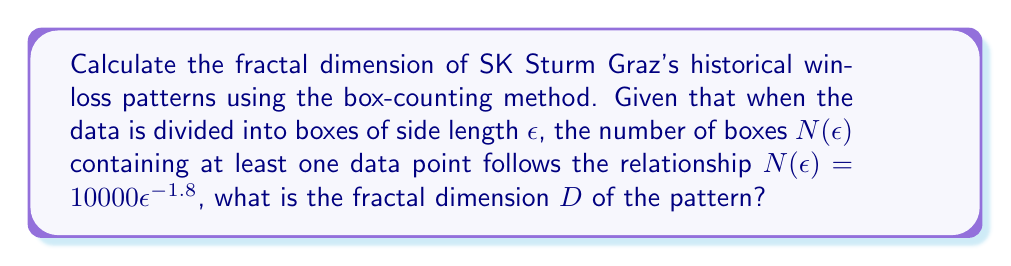Show me your answer to this math problem. To determine the fractal dimension using the box-counting method, we follow these steps:

1. Recall the box-counting dimension formula:
   $$D = \lim_{\epsilon \to 0} \frac{\log N(\epsilon)}{\log(1/\epsilon)}$$

2. We're given that $N(\epsilon) = 10000\epsilon^{-1.8}$

3. Take the logarithm of both sides:
   $$\log N(\epsilon) = \log(10000\epsilon^{-1.8})$$

4. Use the properties of logarithms:
   $$\log N(\epsilon) = \log 10000 + \log(\epsilon^{-1.8})$$
   $$\log N(\epsilon) = 4 - 1.8\log(\epsilon)$$

5. Divide both sides by $\log(1/\epsilon)$:
   $$\frac{\log N(\epsilon)}{\log(1/\epsilon)} = \frac{4}{\log(1/\epsilon)} + 1.8$$

6. As $\epsilon \to 0$, $\log(1/\epsilon) \to \infty$, so $\frac{4}{\log(1/\epsilon)} \to 0$

7. Therefore, the limit as $\epsilon \to 0$ is:
   $$\lim_{\epsilon \to 0} \frac{\log N(\epsilon)}{\log(1/\epsilon)} = 1.8$$

8. This limit is equal to the fractal dimension $D$
Answer: $D = 1.8$ 